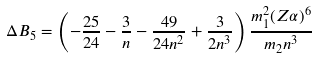<formula> <loc_0><loc_0><loc_500><loc_500>\Delta B _ { 5 } = \left ( - \frac { 2 5 } { 2 4 } - \frac { 3 } { n } - \frac { 4 9 } { 2 4 n ^ { 2 } } + \frac { 3 } { 2 n ^ { 3 } } \right ) \frac { m _ { 1 } ^ { 2 } ( Z \alpha ) ^ { 6 } } { m _ { 2 } n ^ { 3 } }</formula> 